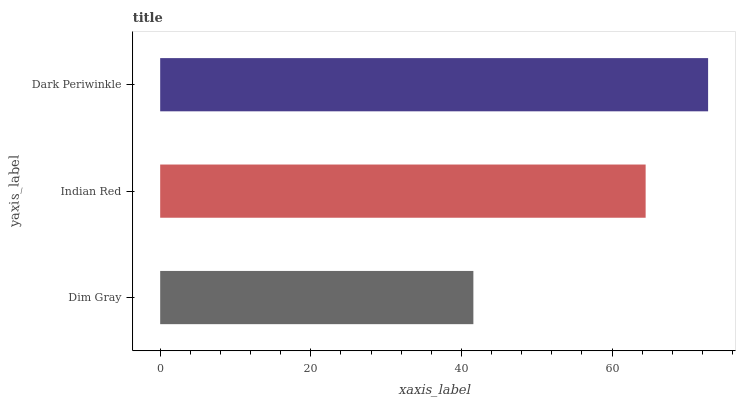Is Dim Gray the minimum?
Answer yes or no. Yes. Is Dark Periwinkle the maximum?
Answer yes or no. Yes. Is Indian Red the minimum?
Answer yes or no. No. Is Indian Red the maximum?
Answer yes or no. No. Is Indian Red greater than Dim Gray?
Answer yes or no. Yes. Is Dim Gray less than Indian Red?
Answer yes or no. Yes. Is Dim Gray greater than Indian Red?
Answer yes or no. No. Is Indian Red less than Dim Gray?
Answer yes or no. No. Is Indian Red the high median?
Answer yes or no. Yes. Is Indian Red the low median?
Answer yes or no. Yes. Is Dark Periwinkle the high median?
Answer yes or no. No. Is Dark Periwinkle the low median?
Answer yes or no. No. 